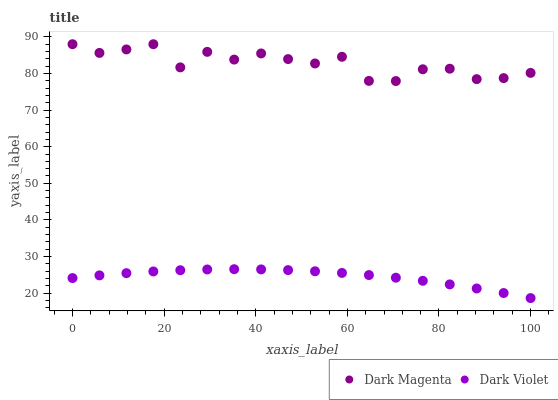Does Dark Violet have the minimum area under the curve?
Answer yes or no. Yes. Does Dark Magenta have the maximum area under the curve?
Answer yes or no. Yes. Does Dark Violet have the maximum area under the curve?
Answer yes or no. No. Is Dark Violet the smoothest?
Answer yes or no. Yes. Is Dark Magenta the roughest?
Answer yes or no. Yes. Is Dark Violet the roughest?
Answer yes or no. No. Does Dark Violet have the lowest value?
Answer yes or no. Yes. Does Dark Magenta have the highest value?
Answer yes or no. Yes. Does Dark Violet have the highest value?
Answer yes or no. No. Is Dark Violet less than Dark Magenta?
Answer yes or no. Yes. Is Dark Magenta greater than Dark Violet?
Answer yes or no. Yes. Does Dark Violet intersect Dark Magenta?
Answer yes or no. No. 